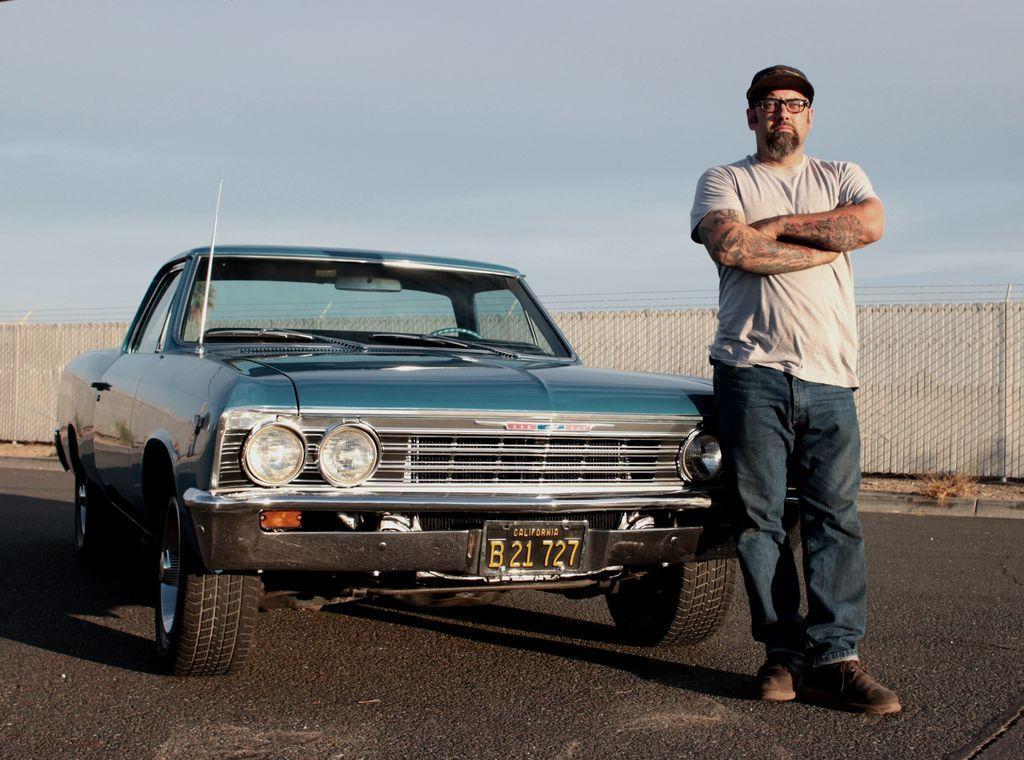Could you give a brief overview of what you see in this image? In this image, we can see a vehicle on the road and there is a man wearing glasses and a cap. In the background, there is a fence. At the top, there is sky. 